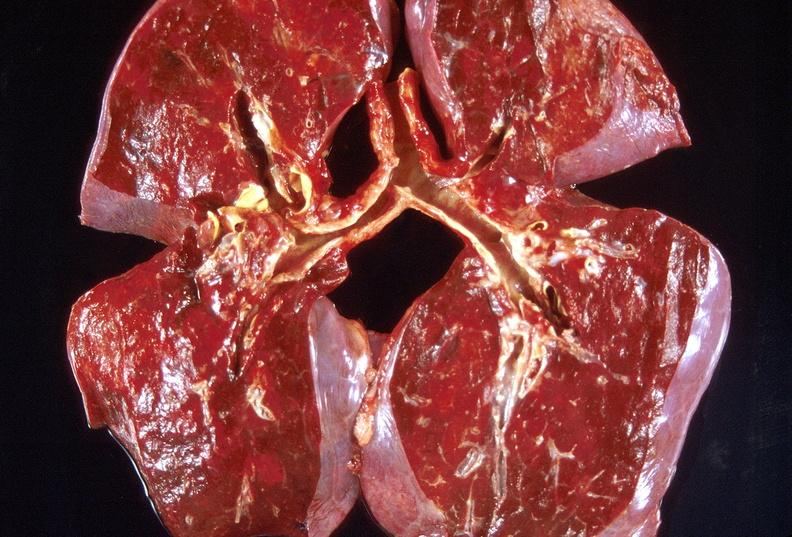does this image show lung, organizing pneumonia?
Answer the question using a single word or phrase. Yes 